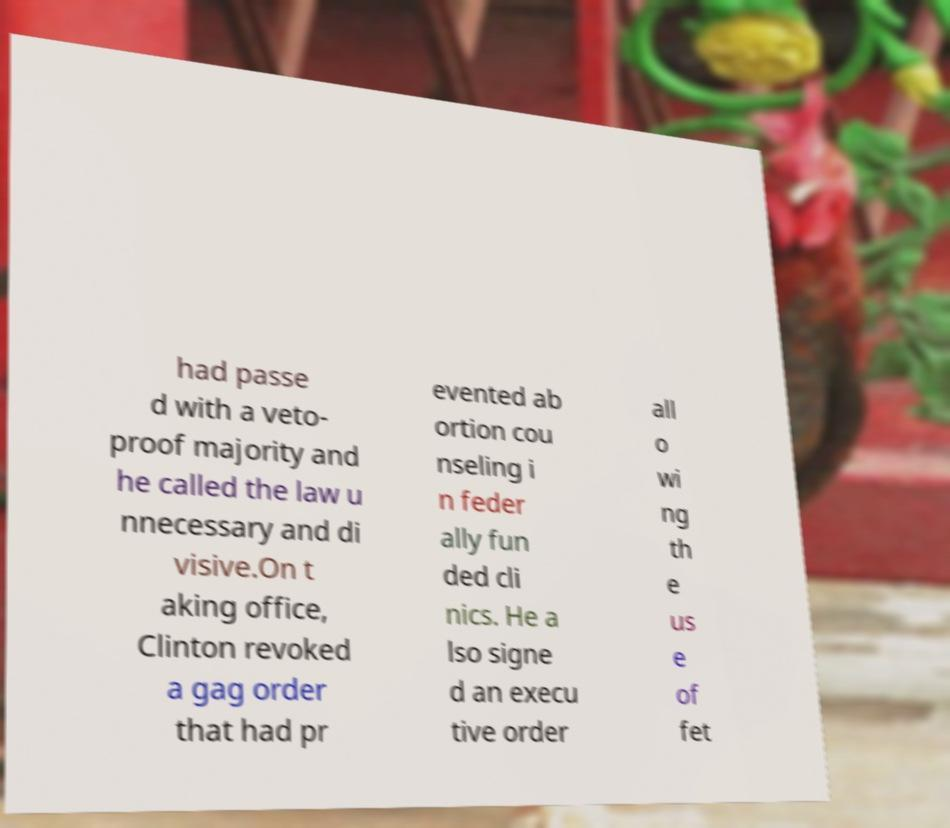What messages or text are displayed in this image? I need them in a readable, typed format. had passe d with a veto- proof majority and he called the law u nnecessary and di visive.On t aking office, Clinton revoked a gag order that had pr evented ab ortion cou nseling i n feder ally fun ded cli nics. He a lso signe d an execu tive order all o wi ng th e us e of fet 